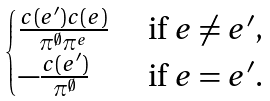Convert formula to latex. <formula><loc_0><loc_0><loc_500><loc_500>\begin{cases} \frac { c ( e ^ { \prime } ) c ( e ) } { \pi ^ { \emptyset } \pi ^ { e } } & \text { if $e\neq e^{\prime}$,} \\ - \frac { c ( e ^ { \prime } ) } { \pi ^ { \emptyset } } & \text { if $e=e^{\prime}$.} \end{cases}</formula> 